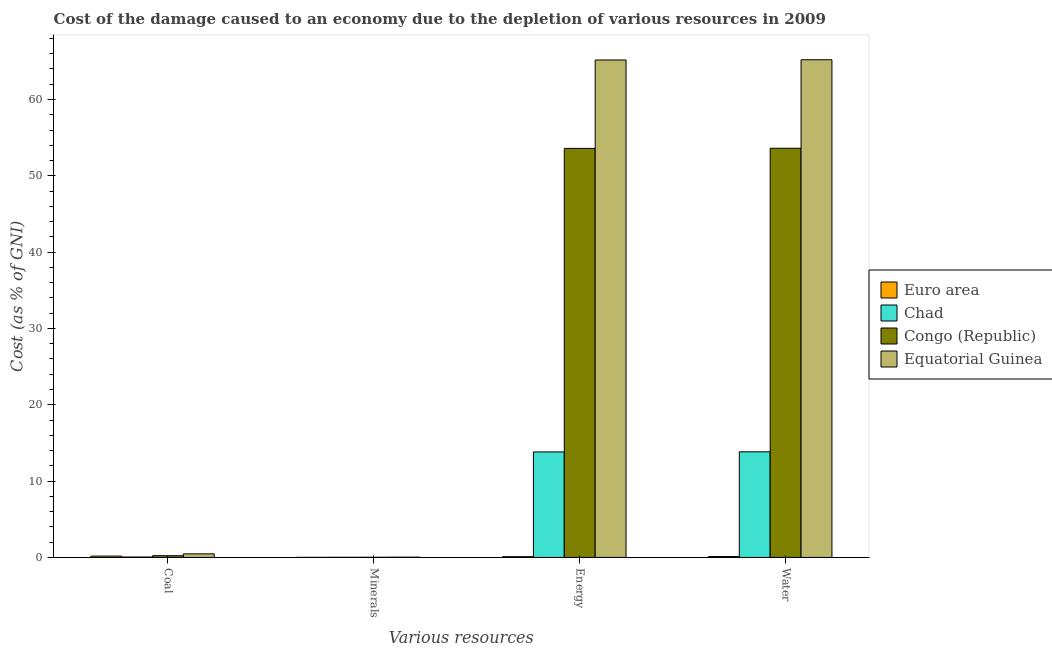How many different coloured bars are there?
Your response must be concise. 4. How many groups of bars are there?
Your answer should be very brief. 4. Are the number of bars per tick equal to the number of legend labels?
Your answer should be compact. Yes. Are the number of bars on each tick of the X-axis equal?
Offer a terse response. Yes. How many bars are there on the 1st tick from the left?
Provide a short and direct response. 4. What is the label of the 2nd group of bars from the left?
Ensure brevity in your answer.  Minerals. What is the cost of damage due to depletion of energy in Equatorial Guinea?
Offer a terse response. 65.18. Across all countries, what is the maximum cost of damage due to depletion of coal?
Provide a succinct answer. 0.47. Across all countries, what is the minimum cost of damage due to depletion of minerals?
Provide a succinct answer. 0.01. In which country was the cost of damage due to depletion of water maximum?
Provide a succinct answer. Equatorial Guinea. What is the total cost of damage due to depletion of coal in the graph?
Provide a succinct answer. 0.92. What is the difference between the cost of damage due to depletion of energy in Chad and that in Equatorial Guinea?
Provide a succinct answer. -51.35. What is the difference between the cost of damage due to depletion of minerals in Congo (Republic) and the cost of damage due to depletion of coal in Euro area?
Make the answer very short. -0.15. What is the average cost of damage due to depletion of minerals per country?
Provide a succinct answer. 0.02. What is the difference between the cost of damage due to depletion of minerals and cost of damage due to depletion of energy in Euro area?
Your answer should be compact. -0.09. What is the ratio of the cost of damage due to depletion of water in Equatorial Guinea to that in Euro area?
Provide a succinct answer. 586.73. Is the cost of damage due to depletion of water in Euro area less than that in Equatorial Guinea?
Give a very brief answer. Yes. What is the difference between the highest and the second highest cost of damage due to depletion of minerals?
Ensure brevity in your answer.  0.01. What is the difference between the highest and the lowest cost of damage due to depletion of water?
Your answer should be compact. 65.1. Is the sum of the cost of damage due to depletion of coal in Equatorial Guinea and Congo (Republic) greater than the maximum cost of damage due to depletion of energy across all countries?
Make the answer very short. No. What does the 4th bar from the left in Energy represents?
Your answer should be compact. Equatorial Guinea. What does the 3rd bar from the right in Water represents?
Offer a very short reply. Chad. Is it the case that in every country, the sum of the cost of damage due to depletion of coal and cost of damage due to depletion of minerals is greater than the cost of damage due to depletion of energy?
Give a very brief answer. No. What is the difference between two consecutive major ticks on the Y-axis?
Provide a succinct answer. 10. Are the values on the major ticks of Y-axis written in scientific E-notation?
Provide a short and direct response. No. Does the graph contain grids?
Make the answer very short. No. How are the legend labels stacked?
Offer a terse response. Vertical. What is the title of the graph?
Offer a terse response. Cost of the damage caused to an economy due to the depletion of various resources in 2009 . Does "Tajikistan" appear as one of the legend labels in the graph?
Your answer should be compact. No. What is the label or title of the X-axis?
Provide a succinct answer. Various resources. What is the label or title of the Y-axis?
Provide a short and direct response. Cost (as % of GNI). What is the Cost (as % of GNI) of Euro area in Coal?
Keep it short and to the point. 0.17. What is the Cost (as % of GNI) of Chad in Coal?
Your response must be concise. 0.05. What is the Cost (as % of GNI) in Congo (Republic) in Coal?
Offer a very short reply. 0.22. What is the Cost (as % of GNI) in Equatorial Guinea in Coal?
Ensure brevity in your answer.  0.47. What is the Cost (as % of GNI) of Euro area in Minerals?
Offer a terse response. 0.01. What is the Cost (as % of GNI) of Chad in Minerals?
Offer a terse response. 0.02. What is the Cost (as % of GNI) in Congo (Republic) in Minerals?
Your response must be concise. 0.02. What is the Cost (as % of GNI) in Equatorial Guinea in Minerals?
Your answer should be compact. 0.03. What is the Cost (as % of GNI) of Euro area in Energy?
Offer a terse response. 0.1. What is the Cost (as % of GNI) of Chad in Energy?
Keep it short and to the point. 13.82. What is the Cost (as % of GNI) in Congo (Republic) in Energy?
Your answer should be compact. 53.6. What is the Cost (as % of GNI) of Equatorial Guinea in Energy?
Offer a terse response. 65.18. What is the Cost (as % of GNI) in Euro area in Water?
Your answer should be very brief. 0.11. What is the Cost (as % of GNI) in Chad in Water?
Your answer should be compact. 13.84. What is the Cost (as % of GNI) of Congo (Republic) in Water?
Provide a short and direct response. 53.61. What is the Cost (as % of GNI) of Equatorial Guinea in Water?
Give a very brief answer. 65.21. Across all Various resources, what is the maximum Cost (as % of GNI) of Euro area?
Your answer should be compact. 0.17. Across all Various resources, what is the maximum Cost (as % of GNI) of Chad?
Provide a short and direct response. 13.84. Across all Various resources, what is the maximum Cost (as % of GNI) of Congo (Republic)?
Your response must be concise. 53.61. Across all Various resources, what is the maximum Cost (as % of GNI) in Equatorial Guinea?
Offer a very short reply. 65.21. Across all Various resources, what is the minimum Cost (as % of GNI) in Euro area?
Keep it short and to the point. 0.01. Across all Various resources, what is the minimum Cost (as % of GNI) in Chad?
Provide a succinct answer. 0.02. Across all Various resources, what is the minimum Cost (as % of GNI) in Congo (Republic)?
Your response must be concise. 0.02. Across all Various resources, what is the minimum Cost (as % of GNI) of Equatorial Guinea?
Ensure brevity in your answer.  0.03. What is the total Cost (as % of GNI) in Euro area in the graph?
Keep it short and to the point. 0.39. What is the total Cost (as % of GNI) in Chad in the graph?
Your answer should be compact. 27.73. What is the total Cost (as % of GNI) in Congo (Republic) in the graph?
Ensure brevity in your answer.  107.45. What is the total Cost (as % of GNI) of Equatorial Guinea in the graph?
Ensure brevity in your answer.  130.89. What is the difference between the Cost (as % of GNI) in Euro area in Coal and that in Minerals?
Provide a short and direct response. 0.17. What is the difference between the Cost (as % of GNI) in Chad in Coal and that in Minerals?
Keep it short and to the point. 0.03. What is the difference between the Cost (as % of GNI) of Congo (Republic) in Coal and that in Minerals?
Offer a very short reply. 0.21. What is the difference between the Cost (as % of GNI) in Equatorial Guinea in Coal and that in Minerals?
Your answer should be compact. 0.44. What is the difference between the Cost (as % of GNI) in Euro area in Coal and that in Energy?
Your answer should be compact. 0.07. What is the difference between the Cost (as % of GNI) of Chad in Coal and that in Energy?
Your answer should be very brief. -13.77. What is the difference between the Cost (as % of GNI) of Congo (Republic) in Coal and that in Energy?
Offer a terse response. -53.37. What is the difference between the Cost (as % of GNI) of Equatorial Guinea in Coal and that in Energy?
Ensure brevity in your answer.  -64.71. What is the difference between the Cost (as % of GNI) of Euro area in Coal and that in Water?
Provide a short and direct response. 0.06. What is the difference between the Cost (as % of GNI) in Chad in Coal and that in Water?
Provide a short and direct response. -13.79. What is the difference between the Cost (as % of GNI) of Congo (Republic) in Coal and that in Water?
Provide a succinct answer. -53.39. What is the difference between the Cost (as % of GNI) of Equatorial Guinea in Coal and that in Water?
Your response must be concise. -64.74. What is the difference between the Cost (as % of GNI) of Euro area in Minerals and that in Energy?
Make the answer very short. -0.09. What is the difference between the Cost (as % of GNI) of Chad in Minerals and that in Energy?
Give a very brief answer. -13.81. What is the difference between the Cost (as % of GNI) in Congo (Republic) in Minerals and that in Energy?
Make the answer very short. -53.58. What is the difference between the Cost (as % of GNI) of Equatorial Guinea in Minerals and that in Energy?
Offer a very short reply. -65.15. What is the difference between the Cost (as % of GNI) in Euro area in Minerals and that in Water?
Make the answer very short. -0.11. What is the difference between the Cost (as % of GNI) of Chad in Minerals and that in Water?
Make the answer very short. -13.82. What is the difference between the Cost (as % of GNI) of Congo (Republic) in Minerals and that in Water?
Your answer should be compact. -53.6. What is the difference between the Cost (as % of GNI) of Equatorial Guinea in Minerals and that in Water?
Provide a succinct answer. -65.18. What is the difference between the Cost (as % of GNI) of Euro area in Energy and that in Water?
Ensure brevity in your answer.  -0.01. What is the difference between the Cost (as % of GNI) in Chad in Energy and that in Water?
Your response must be concise. -0.02. What is the difference between the Cost (as % of GNI) in Congo (Republic) in Energy and that in Water?
Make the answer very short. -0.02. What is the difference between the Cost (as % of GNI) in Equatorial Guinea in Energy and that in Water?
Keep it short and to the point. -0.03. What is the difference between the Cost (as % of GNI) of Euro area in Coal and the Cost (as % of GNI) of Chad in Minerals?
Your answer should be compact. 0.16. What is the difference between the Cost (as % of GNI) in Euro area in Coal and the Cost (as % of GNI) in Congo (Republic) in Minerals?
Your response must be concise. 0.15. What is the difference between the Cost (as % of GNI) of Euro area in Coal and the Cost (as % of GNI) of Equatorial Guinea in Minerals?
Provide a short and direct response. 0.14. What is the difference between the Cost (as % of GNI) of Chad in Coal and the Cost (as % of GNI) of Congo (Republic) in Minerals?
Make the answer very short. 0.03. What is the difference between the Cost (as % of GNI) in Chad in Coal and the Cost (as % of GNI) in Equatorial Guinea in Minerals?
Provide a succinct answer. 0.02. What is the difference between the Cost (as % of GNI) of Congo (Republic) in Coal and the Cost (as % of GNI) of Equatorial Guinea in Minerals?
Your answer should be compact. 0.19. What is the difference between the Cost (as % of GNI) in Euro area in Coal and the Cost (as % of GNI) in Chad in Energy?
Make the answer very short. -13.65. What is the difference between the Cost (as % of GNI) in Euro area in Coal and the Cost (as % of GNI) in Congo (Republic) in Energy?
Provide a succinct answer. -53.42. What is the difference between the Cost (as % of GNI) of Euro area in Coal and the Cost (as % of GNI) of Equatorial Guinea in Energy?
Offer a terse response. -65. What is the difference between the Cost (as % of GNI) of Chad in Coal and the Cost (as % of GNI) of Congo (Republic) in Energy?
Your answer should be very brief. -53.54. What is the difference between the Cost (as % of GNI) in Chad in Coal and the Cost (as % of GNI) in Equatorial Guinea in Energy?
Make the answer very short. -65.13. What is the difference between the Cost (as % of GNI) of Congo (Republic) in Coal and the Cost (as % of GNI) of Equatorial Guinea in Energy?
Provide a succinct answer. -64.95. What is the difference between the Cost (as % of GNI) of Euro area in Coal and the Cost (as % of GNI) of Chad in Water?
Provide a short and direct response. -13.67. What is the difference between the Cost (as % of GNI) of Euro area in Coal and the Cost (as % of GNI) of Congo (Republic) in Water?
Make the answer very short. -53.44. What is the difference between the Cost (as % of GNI) in Euro area in Coal and the Cost (as % of GNI) in Equatorial Guinea in Water?
Your answer should be very brief. -65.03. What is the difference between the Cost (as % of GNI) of Chad in Coal and the Cost (as % of GNI) of Congo (Republic) in Water?
Make the answer very short. -53.56. What is the difference between the Cost (as % of GNI) in Chad in Coal and the Cost (as % of GNI) in Equatorial Guinea in Water?
Provide a succinct answer. -65.16. What is the difference between the Cost (as % of GNI) in Congo (Republic) in Coal and the Cost (as % of GNI) in Equatorial Guinea in Water?
Keep it short and to the point. -64.98. What is the difference between the Cost (as % of GNI) in Euro area in Minerals and the Cost (as % of GNI) in Chad in Energy?
Offer a terse response. -13.82. What is the difference between the Cost (as % of GNI) in Euro area in Minerals and the Cost (as % of GNI) in Congo (Republic) in Energy?
Offer a terse response. -53.59. What is the difference between the Cost (as % of GNI) in Euro area in Minerals and the Cost (as % of GNI) in Equatorial Guinea in Energy?
Provide a succinct answer. -65.17. What is the difference between the Cost (as % of GNI) in Chad in Minerals and the Cost (as % of GNI) in Congo (Republic) in Energy?
Offer a terse response. -53.58. What is the difference between the Cost (as % of GNI) of Chad in Minerals and the Cost (as % of GNI) of Equatorial Guinea in Energy?
Provide a short and direct response. -65.16. What is the difference between the Cost (as % of GNI) of Congo (Republic) in Minerals and the Cost (as % of GNI) of Equatorial Guinea in Energy?
Make the answer very short. -65.16. What is the difference between the Cost (as % of GNI) in Euro area in Minerals and the Cost (as % of GNI) in Chad in Water?
Provide a succinct answer. -13.83. What is the difference between the Cost (as % of GNI) of Euro area in Minerals and the Cost (as % of GNI) of Congo (Republic) in Water?
Provide a short and direct response. -53.61. What is the difference between the Cost (as % of GNI) of Euro area in Minerals and the Cost (as % of GNI) of Equatorial Guinea in Water?
Offer a very short reply. -65.2. What is the difference between the Cost (as % of GNI) in Chad in Minerals and the Cost (as % of GNI) in Congo (Republic) in Water?
Offer a very short reply. -53.6. What is the difference between the Cost (as % of GNI) of Chad in Minerals and the Cost (as % of GNI) of Equatorial Guinea in Water?
Make the answer very short. -65.19. What is the difference between the Cost (as % of GNI) in Congo (Republic) in Minerals and the Cost (as % of GNI) in Equatorial Guinea in Water?
Provide a succinct answer. -65.19. What is the difference between the Cost (as % of GNI) of Euro area in Energy and the Cost (as % of GNI) of Chad in Water?
Your answer should be compact. -13.74. What is the difference between the Cost (as % of GNI) of Euro area in Energy and the Cost (as % of GNI) of Congo (Republic) in Water?
Provide a short and direct response. -53.52. What is the difference between the Cost (as % of GNI) of Euro area in Energy and the Cost (as % of GNI) of Equatorial Guinea in Water?
Provide a short and direct response. -65.11. What is the difference between the Cost (as % of GNI) of Chad in Energy and the Cost (as % of GNI) of Congo (Republic) in Water?
Offer a very short reply. -39.79. What is the difference between the Cost (as % of GNI) in Chad in Energy and the Cost (as % of GNI) in Equatorial Guinea in Water?
Offer a very short reply. -51.39. What is the difference between the Cost (as % of GNI) of Congo (Republic) in Energy and the Cost (as % of GNI) of Equatorial Guinea in Water?
Make the answer very short. -11.61. What is the average Cost (as % of GNI) in Euro area per Various resources?
Offer a terse response. 0.1. What is the average Cost (as % of GNI) in Chad per Various resources?
Give a very brief answer. 6.93. What is the average Cost (as % of GNI) of Congo (Republic) per Various resources?
Your answer should be compact. 26.86. What is the average Cost (as % of GNI) of Equatorial Guinea per Various resources?
Your answer should be very brief. 32.72. What is the difference between the Cost (as % of GNI) in Euro area and Cost (as % of GNI) in Chad in Coal?
Keep it short and to the point. 0.12. What is the difference between the Cost (as % of GNI) in Euro area and Cost (as % of GNI) in Congo (Republic) in Coal?
Provide a succinct answer. -0.05. What is the difference between the Cost (as % of GNI) of Euro area and Cost (as % of GNI) of Equatorial Guinea in Coal?
Ensure brevity in your answer.  -0.29. What is the difference between the Cost (as % of GNI) in Chad and Cost (as % of GNI) in Congo (Republic) in Coal?
Provide a short and direct response. -0.17. What is the difference between the Cost (as % of GNI) of Chad and Cost (as % of GNI) of Equatorial Guinea in Coal?
Provide a short and direct response. -0.42. What is the difference between the Cost (as % of GNI) of Congo (Republic) and Cost (as % of GNI) of Equatorial Guinea in Coal?
Your answer should be very brief. -0.24. What is the difference between the Cost (as % of GNI) of Euro area and Cost (as % of GNI) of Chad in Minerals?
Offer a terse response. -0.01. What is the difference between the Cost (as % of GNI) of Euro area and Cost (as % of GNI) of Congo (Republic) in Minerals?
Give a very brief answer. -0.01. What is the difference between the Cost (as % of GNI) in Euro area and Cost (as % of GNI) in Equatorial Guinea in Minerals?
Offer a terse response. -0.03. What is the difference between the Cost (as % of GNI) of Chad and Cost (as % of GNI) of Congo (Republic) in Minerals?
Your response must be concise. -0. What is the difference between the Cost (as % of GNI) in Chad and Cost (as % of GNI) in Equatorial Guinea in Minerals?
Keep it short and to the point. -0.02. What is the difference between the Cost (as % of GNI) of Congo (Republic) and Cost (as % of GNI) of Equatorial Guinea in Minerals?
Provide a succinct answer. -0.01. What is the difference between the Cost (as % of GNI) of Euro area and Cost (as % of GNI) of Chad in Energy?
Your answer should be compact. -13.72. What is the difference between the Cost (as % of GNI) of Euro area and Cost (as % of GNI) of Congo (Republic) in Energy?
Offer a very short reply. -53.5. What is the difference between the Cost (as % of GNI) in Euro area and Cost (as % of GNI) in Equatorial Guinea in Energy?
Give a very brief answer. -65.08. What is the difference between the Cost (as % of GNI) in Chad and Cost (as % of GNI) in Congo (Republic) in Energy?
Your answer should be compact. -39.77. What is the difference between the Cost (as % of GNI) in Chad and Cost (as % of GNI) in Equatorial Guinea in Energy?
Offer a very short reply. -51.35. What is the difference between the Cost (as % of GNI) of Congo (Republic) and Cost (as % of GNI) of Equatorial Guinea in Energy?
Your response must be concise. -11.58. What is the difference between the Cost (as % of GNI) of Euro area and Cost (as % of GNI) of Chad in Water?
Keep it short and to the point. -13.73. What is the difference between the Cost (as % of GNI) in Euro area and Cost (as % of GNI) in Congo (Republic) in Water?
Ensure brevity in your answer.  -53.5. What is the difference between the Cost (as % of GNI) in Euro area and Cost (as % of GNI) in Equatorial Guinea in Water?
Keep it short and to the point. -65.1. What is the difference between the Cost (as % of GNI) in Chad and Cost (as % of GNI) in Congo (Republic) in Water?
Provide a succinct answer. -39.78. What is the difference between the Cost (as % of GNI) in Chad and Cost (as % of GNI) in Equatorial Guinea in Water?
Give a very brief answer. -51.37. What is the difference between the Cost (as % of GNI) in Congo (Republic) and Cost (as % of GNI) in Equatorial Guinea in Water?
Give a very brief answer. -11.59. What is the ratio of the Cost (as % of GNI) of Euro area in Coal to that in Minerals?
Provide a succinct answer. 34.84. What is the ratio of the Cost (as % of GNI) in Chad in Coal to that in Minerals?
Make the answer very short. 3.16. What is the ratio of the Cost (as % of GNI) in Congo (Republic) in Coal to that in Minerals?
Your answer should be compact. 11.58. What is the ratio of the Cost (as % of GNI) of Equatorial Guinea in Coal to that in Minerals?
Your response must be concise. 14.87. What is the ratio of the Cost (as % of GNI) in Euro area in Coal to that in Energy?
Your answer should be very brief. 1.75. What is the ratio of the Cost (as % of GNI) of Chad in Coal to that in Energy?
Give a very brief answer. 0. What is the ratio of the Cost (as % of GNI) of Congo (Republic) in Coal to that in Energy?
Offer a terse response. 0. What is the ratio of the Cost (as % of GNI) of Equatorial Guinea in Coal to that in Energy?
Ensure brevity in your answer.  0.01. What is the ratio of the Cost (as % of GNI) of Euro area in Coal to that in Water?
Give a very brief answer. 1.57. What is the ratio of the Cost (as % of GNI) of Chad in Coal to that in Water?
Give a very brief answer. 0. What is the ratio of the Cost (as % of GNI) of Congo (Republic) in Coal to that in Water?
Keep it short and to the point. 0. What is the ratio of the Cost (as % of GNI) of Equatorial Guinea in Coal to that in Water?
Your response must be concise. 0.01. What is the ratio of the Cost (as % of GNI) of Euro area in Minerals to that in Energy?
Offer a terse response. 0.05. What is the ratio of the Cost (as % of GNI) in Chad in Minerals to that in Energy?
Your answer should be very brief. 0. What is the ratio of the Cost (as % of GNI) of Congo (Republic) in Minerals to that in Energy?
Keep it short and to the point. 0. What is the ratio of the Cost (as % of GNI) of Equatorial Guinea in Minerals to that in Energy?
Offer a terse response. 0. What is the ratio of the Cost (as % of GNI) in Euro area in Minerals to that in Water?
Your answer should be compact. 0.04. What is the ratio of the Cost (as % of GNI) of Chad in Minerals to that in Water?
Give a very brief answer. 0. What is the ratio of the Cost (as % of GNI) of Congo (Republic) in Minerals to that in Water?
Provide a short and direct response. 0. What is the ratio of the Cost (as % of GNI) of Equatorial Guinea in Minerals to that in Water?
Your response must be concise. 0. What is the ratio of the Cost (as % of GNI) in Euro area in Energy to that in Water?
Your answer should be very brief. 0.9. What is the ratio of the Cost (as % of GNI) of Chad in Energy to that in Water?
Your answer should be very brief. 1. What is the difference between the highest and the second highest Cost (as % of GNI) of Euro area?
Provide a short and direct response. 0.06. What is the difference between the highest and the second highest Cost (as % of GNI) in Chad?
Offer a terse response. 0.02. What is the difference between the highest and the second highest Cost (as % of GNI) in Congo (Republic)?
Your response must be concise. 0.02. What is the difference between the highest and the second highest Cost (as % of GNI) in Equatorial Guinea?
Ensure brevity in your answer.  0.03. What is the difference between the highest and the lowest Cost (as % of GNI) in Euro area?
Make the answer very short. 0.17. What is the difference between the highest and the lowest Cost (as % of GNI) of Chad?
Your answer should be compact. 13.82. What is the difference between the highest and the lowest Cost (as % of GNI) of Congo (Republic)?
Make the answer very short. 53.6. What is the difference between the highest and the lowest Cost (as % of GNI) of Equatorial Guinea?
Offer a terse response. 65.18. 